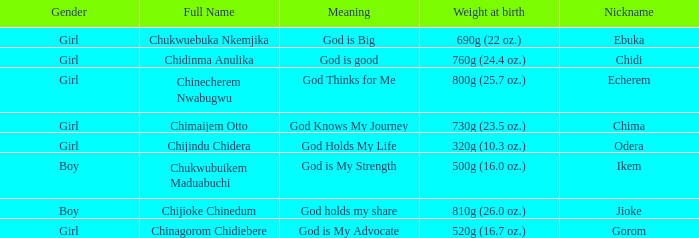How much did the baby who name means God knows my journey weigh at birth? 730g (23.5 oz.). 